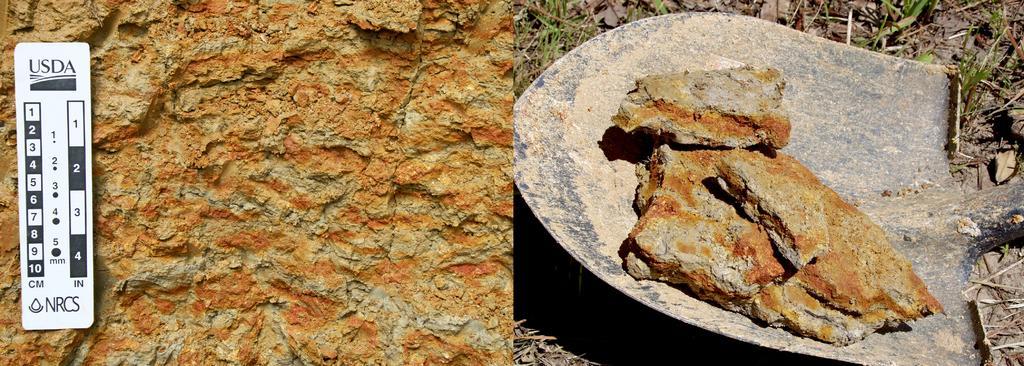In one or two sentences, can you explain what this image depicts? This looks like a collage picture. I think this is the stone. This looks like a digging shovel. I can see few pieces of a stone on the shovel. This is the grass. I can see the watermark on the image. 